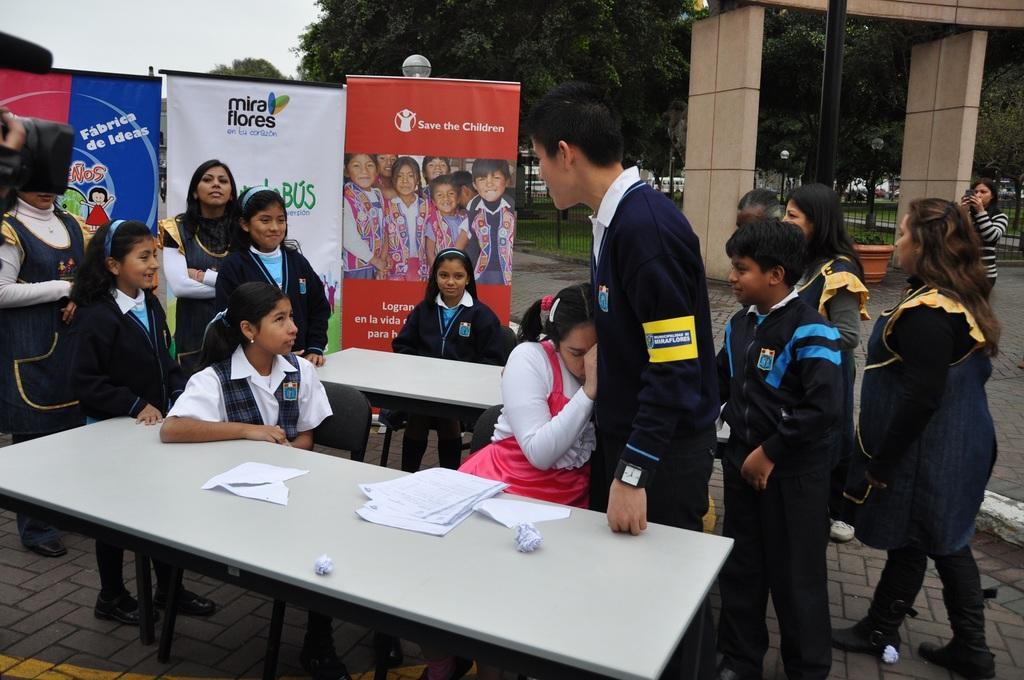Describe this image in one or two sentences. In this picture there is a boy wearing black jacket is standing. Beside there is a girl wearing pink top sitting on the chair. Behind we can see some school student wearing black coat smiling. In the background there are three roller banners. In the front side we can white table with some papers on the top. In the background we can see a brown color arch and some trees. 